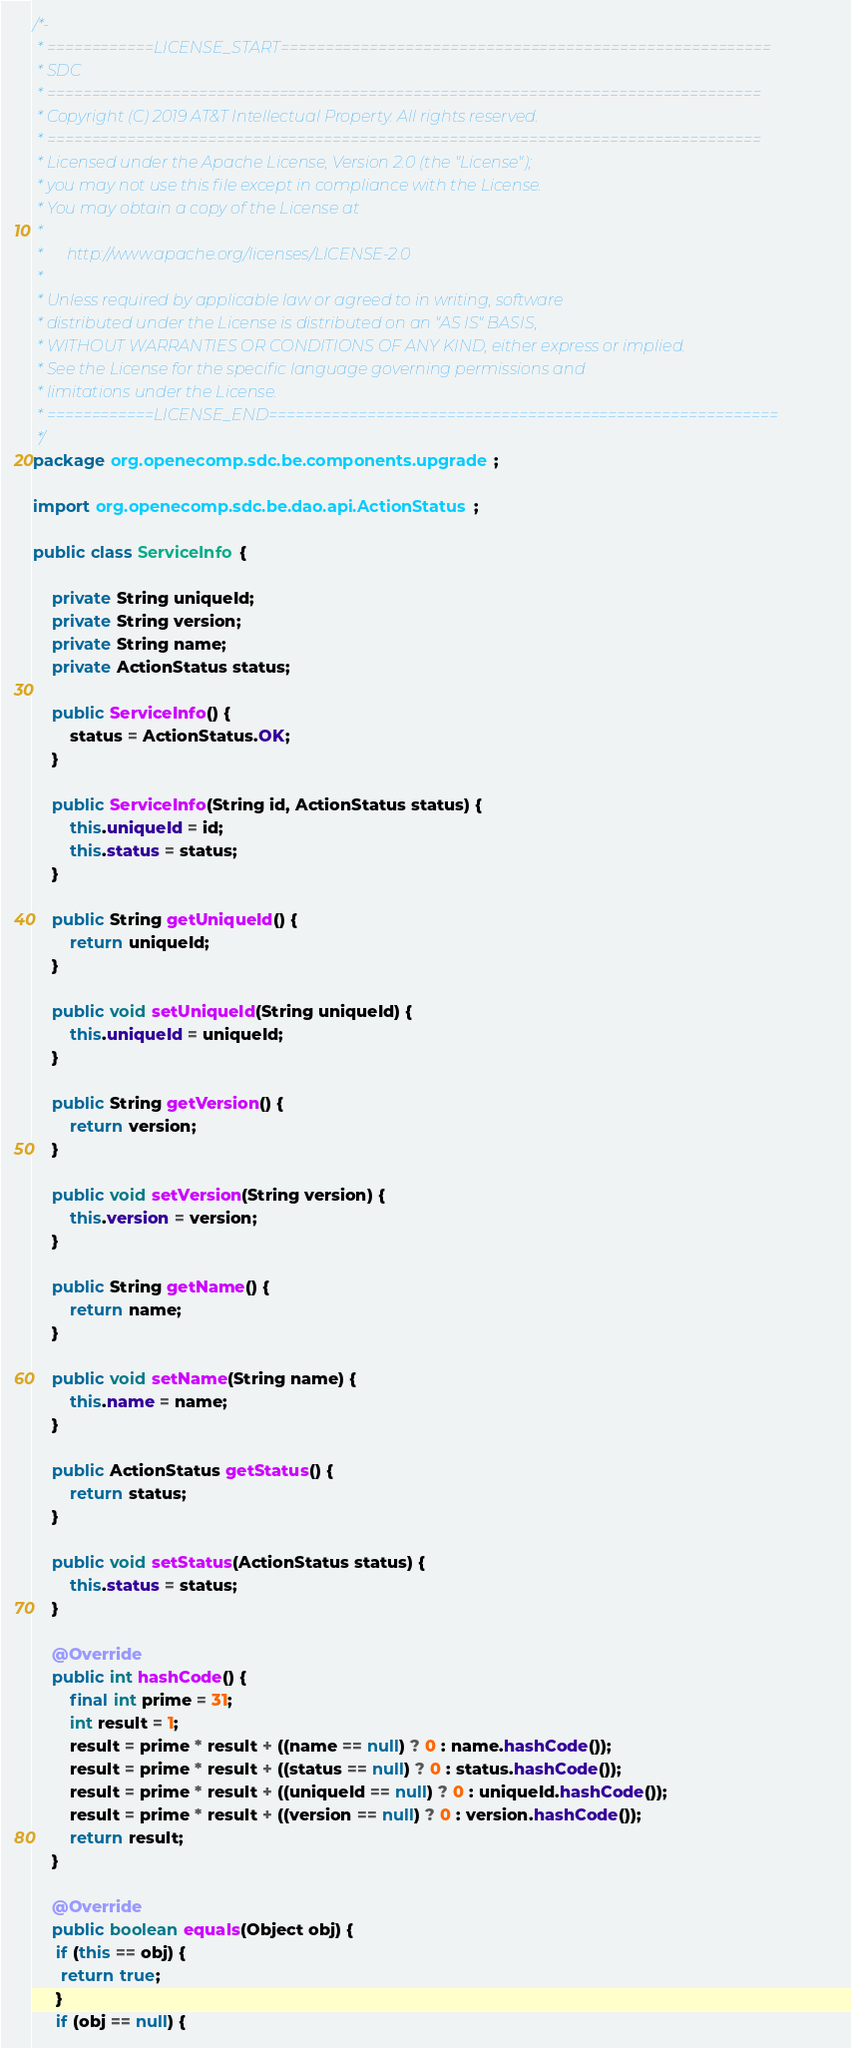<code> <loc_0><loc_0><loc_500><loc_500><_Java_>/*-
 * ============LICENSE_START=======================================================
 * SDC
 * ================================================================================
 * Copyright (C) 2019 AT&T Intellectual Property. All rights reserved.
 * ================================================================================
 * Licensed under the Apache License, Version 2.0 (the "License");
 * you may not use this file except in compliance with the License.
 * You may obtain a copy of the License at
 *
 *      http://www.apache.org/licenses/LICENSE-2.0
 *
 * Unless required by applicable law or agreed to in writing, software
 * distributed under the License is distributed on an "AS IS" BASIS,
 * WITHOUT WARRANTIES OR CONDITIONS OF ANY KIND, either express or implied.
 * See the License for the specific language governing permissions and
 * limitations under the License.
 * ============LICENSE_END=========================================================
 */
package org.openecomp.sdc.be.components.upgrade;

import org.openecomp.sdc.be.dao.api.ActionStatus;

public class ServiceInfo {

    private String uniqueId;
    private String version;
    private String name;
    private ActionStatus status;

    public ServiceInfo() {
        status = ActionStatus.OK;
    }

    public ServiceInfo(String id, ActionStatus status) {
        this.uniqueId = id;
        this.status = status;
    }

    public String getUniqueId() {
        return uniqueId;
    }

    public void setUniqueId(String uniqueId) {
        this.uniqueId = uniqueId;
    }

    public String getVersion() {
        return version;
    }

    public void setVersion(String version) {
        this.version = version;
    }

    public String getName() {
        return name;
    }

    public void setName(String name) {
        this.name = name;
    }

    public ActionStatus getStatus() {
        return status;
    }

    public void setStatus(ActionStatus status) {
        this.status = status;
    }

    @Override
    public int hashCode() {
        final int prime = 31;
        int result = 1;
        result = prime * result + ((name == null) ? 0 : name.hashCode());
        result = prime * result + ((status == null) ? 0 : status.hashCode());
        result = prime * result + ((uniqueId == null) ? 0 : uniqueId.hashCode());
        result = prime * result + ((version == null) ? 0 : version.hashCode());
        return result;
    }

    @Override
    public boolean equals(Object obj) {
     if (this == obj) {
      return true;
     }
     if (obj == null) {</code> 